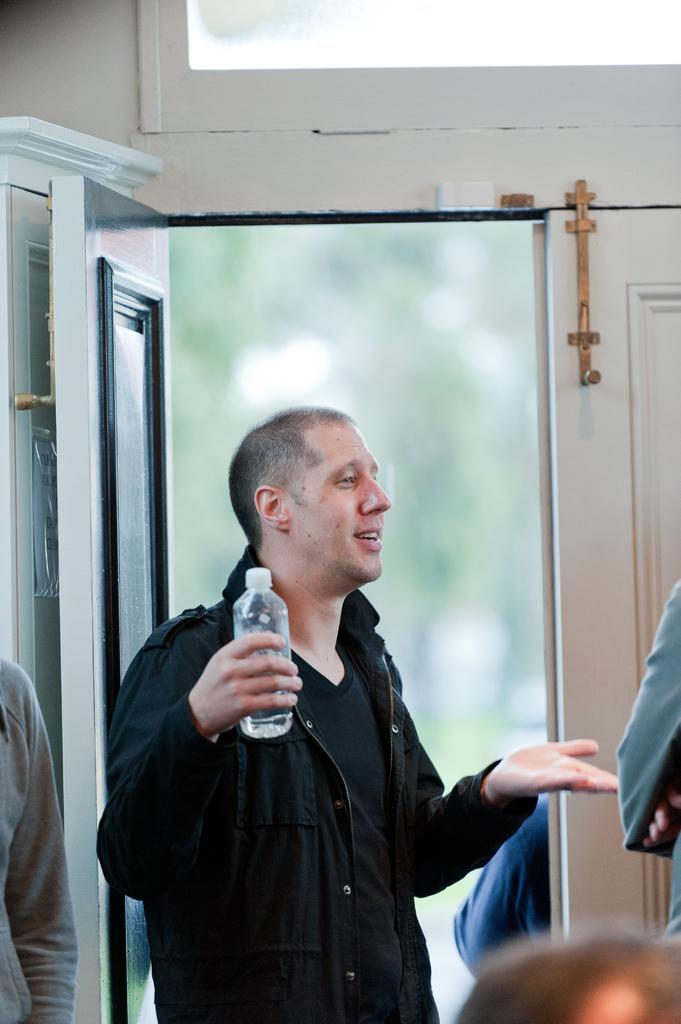What is the man in the image doing? The man is standing in the image and smiling. What is the man holding in his hand? The man is holding a water bottle in his hand. What can be seen near the man in the image? There is a door in the image, and there are persons standing in front of the door. How does the man increase the volume of the bells in the image? There are no bells present in the image, so the man cannot increase their volume. 